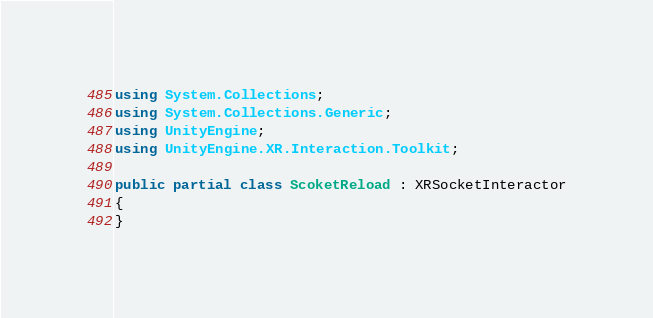<code> <loc_0><loc_0><loc_500><loc_500><_C#_>using System.Collections;
using System.Collections.Generic;
using UnityEngine;
using UnityEngine.XR.Interaction.Toolkit;

public partial class ScoketReload : XRSocketInteractor
{
}
</code> 